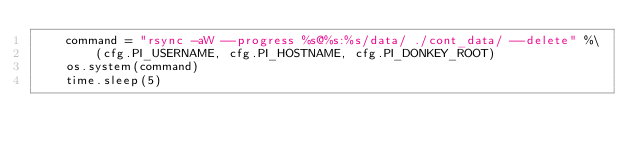Convert code to text. <code><loc_0><loc_0><loc_500><loc_500><_Python_>    command = "rsync -aW --progress %s@%s:%s/data/ ./cont_data/ --delete" %\
        (cfg.PI_USERNAME, cfg.PI_HOSTNAME, cfg.PI_DONKEY_ROOT)
    os.system(command)
    time.sleep(5)
</code> 